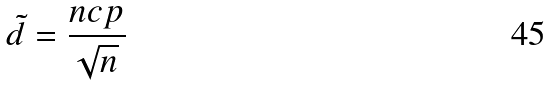<formula> <loc_0><loc_0><loc_500><loc_500>\tilde { d } = \frac { n c p } { \sqrt { n } }</formula> 